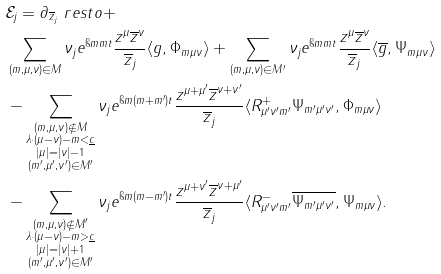Convert formula to latex. <formula><loc_0><loc_0><loc_500><loc_500>& \mathcal { E } _ { j } = \partial _ { \overline { z } _ { j } } \ r e s t o + \\ & \sum _ { ( m , \mu , \nu ) \in M } \nu _ { j } e ^ { \i m m t } \frac { z ^ { \mu } \overline { z } ^ { \nu } } { \overline { z } _ { j } } \langle g , \Phi _ { m \mu \nu } \rangle + \sum _ { ( m , \mu , \nu ) \in M ^ { \prime } } \nu _ { j } e ^ { \i m m t } \frac { z ^ { \mu } \overline { z } ^ { \nu } } { \overline { z } _ { j } } \langle \overline { g } , \Psi _ { m \mu \nu } \rangle \\ & - \sum _ { \substack { ( m , \mu , \nu ) \not \in M \\ \lambda \cdot ( \mu - \nu ) - m < \underline { c } \\ | \mu | = | \nu | - 1 \\ ( m ^ { \prime } , \mu ^ { \prime } , \nu ^ { \prime } ) \in M ^ { \prime } } } \nu _ { j } e ^ { \i m ( m + m ^ { \prime } ) t } \frac { z ^ { \mu + \mu ^ { \prime } } \overline { z } ^ { { \nu } + \nu ^ { \prime } } } { \overline { z } _ { j } } \langle R ^ { + } _ { \mu ^ { \prime } \nu ^ { \prime } m ^ { \prime } } \Psi _ { m ^ { \prime } \mu ^ { \prime } \nu ^ { \prime } } , \Phi _ { m \mu \nu } \rangle \\ & - \sum _ { \substack { ( m , \mu , \nu ) \not \in M ^ { \prime } \\ \lambda \cdot ( \mu - \nu ) - m > \underline { c } \\ | \mu | = | \nu | + 1 \\ ( m ^ { \prime } , \mu ^ { \prime } , \nu ^ { \prime } ) \in M ^ { \prime } } } \nu _ { j } e ^ { \i m ( m - m ^ { \prime } ) t } \frac { z ^ { \mu + \nu ^ { \prime } } \overline { z } ^ { { \nu } + \mu ^ { \prime } } } { \overline { z } _ { j } } \langle R ^ { - } _ { \mu ^ { \prime } \nu ^ { \prime } m ^ { \prime } } \overline { \Psi _ { m ^ { \prime } \mu ^ { \prime } \nu ^ { \prime } } } , \Psi _ { m \mu \nu } \rangle .</formula> 